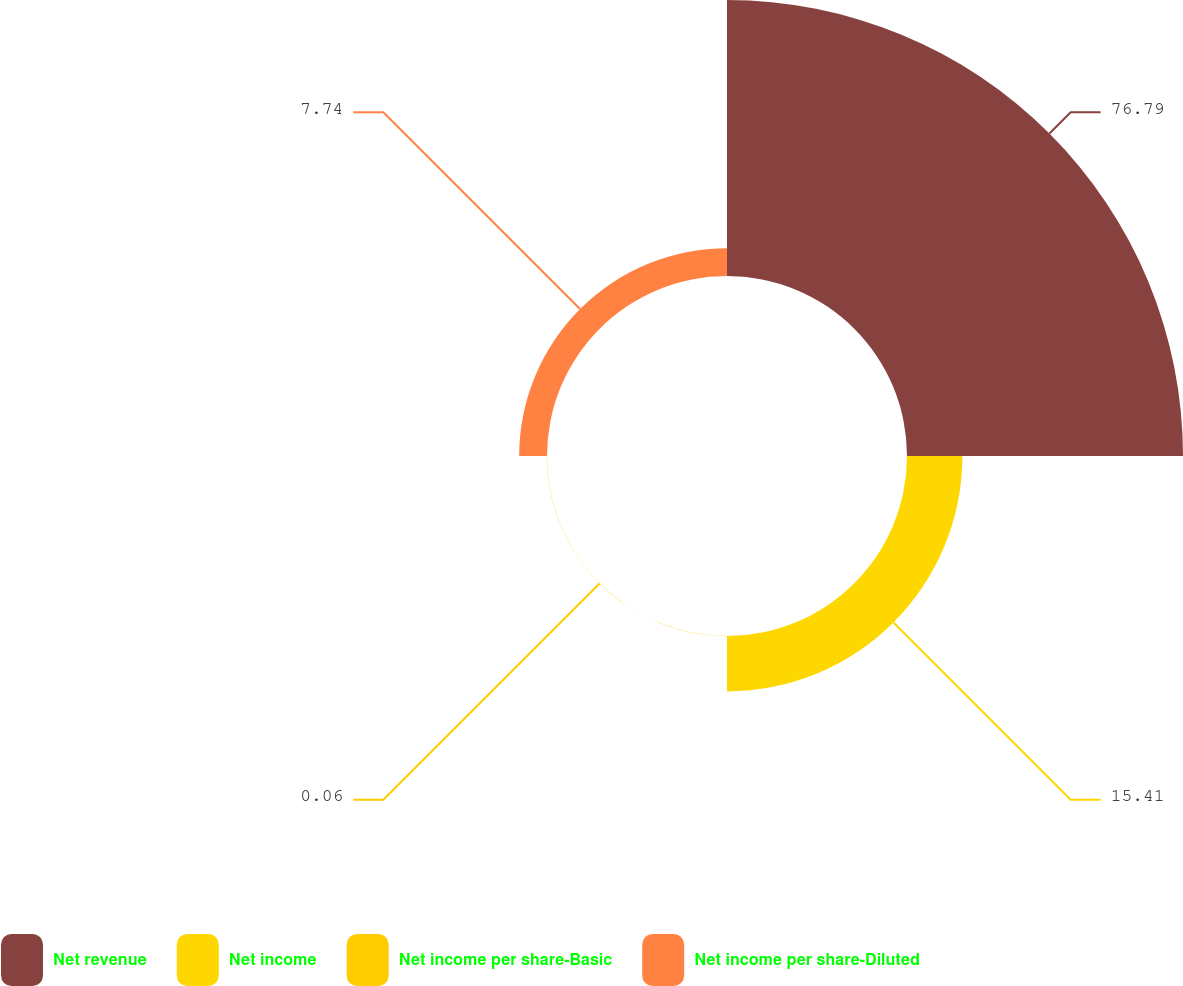Convert chart. <chart><loc_0><loc_0><loc_500><loc_500><pie_chart><fcel>Net revenue<fcel>Net income<fcel>Net income per share-Basic<fcel>Net income per share-Diluted<nl><fcel>76.79%<fcel>15.41%<fcel>0.06%<fcel>7.74%<nl></chart> 